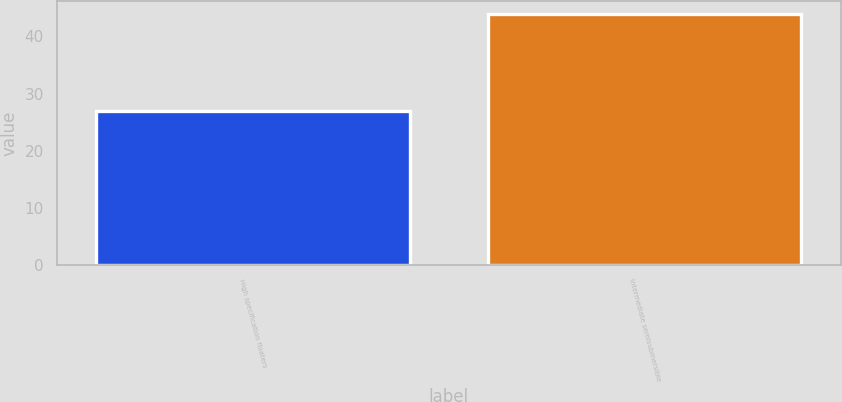<chart> <loc_0><loc_0><loc_500><loc_500><bar_chart><fcel>High specification floaters<fcel>Intermediate semisubmersible<nl><fcel>27<fcel>44<nl></chart> 